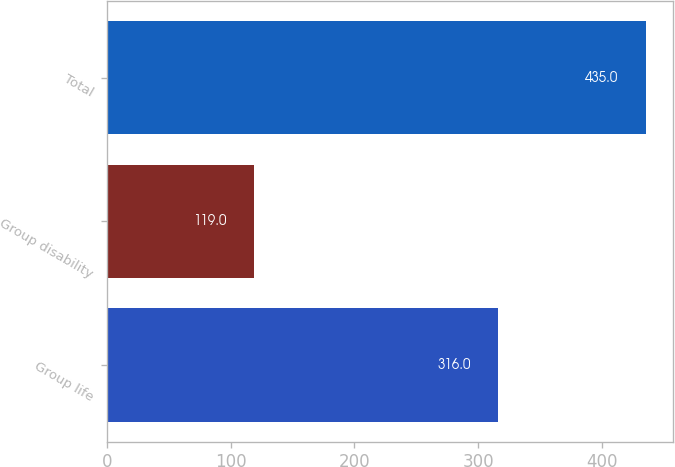Convert chart to OTSL. <chart><loc_0><loc_0><loc_500><loc_500><bar_chart><fcel>Group life<fcel>Group disability<fcel>Total<nl><fcel>316<fcel>119<fcel>435<nl></chart> 